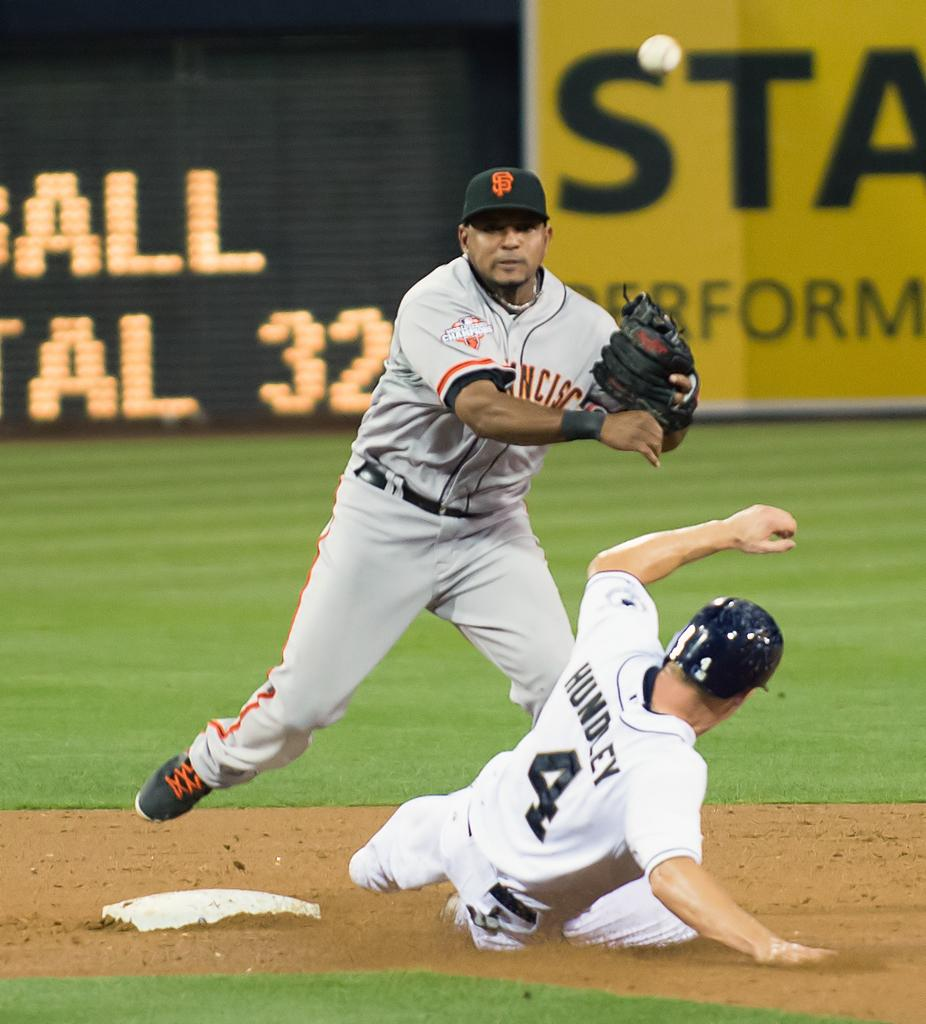<image>
Summarize the visual content of the image. hundley #4 sliding into base as san francisco player waiting for ball 